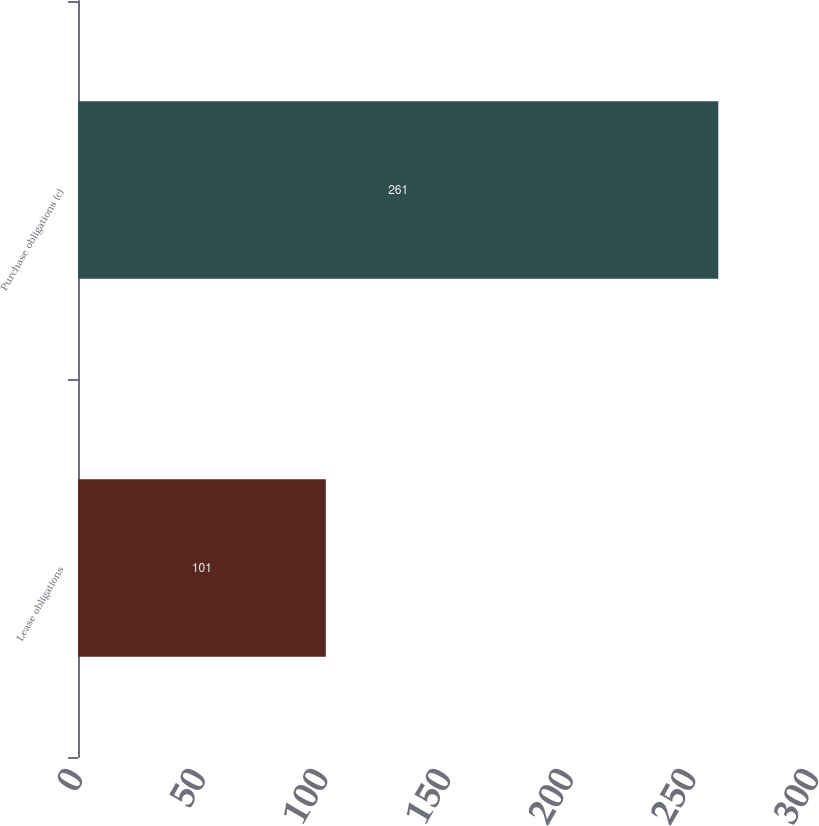Convert chart to OTSL. <chart><loc_0><loc_0><loc_500><loc_500><bar_chart><fcel>Lease obligations<fcel>Purchase obligations (c)<nl><fcel>101<fcel>261<nl></chart> 